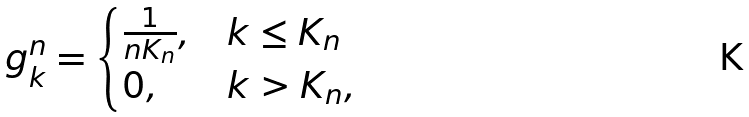Convert formula to latex. <formula><loc_0><loc_0><loc_500><loc_500>g ^ { n } _ { k } = \begin{cases} \frac { 1 } { n K _ { n } } , & k \leq K _ { n } \\ 0 , & k > K _ { n } , \end{cases}</formula> 